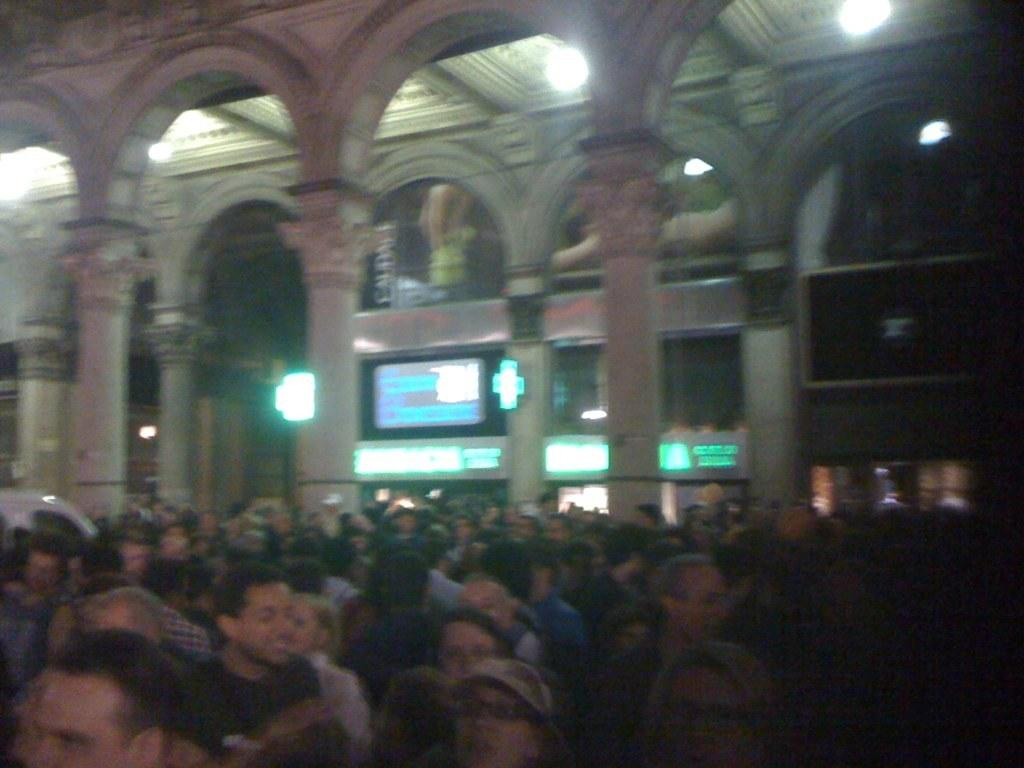Who or what can be seen in the image? There are people in the image. What can be seen in the background of the image? There are walls, lights, screens, and other objects in the background of the image. Can you describe the walls in the background? The walls in the background are visible but no specific details about them can be determined from the image. What might the screens in the background be displaying? The screens in the background could be displaying various types of content, but it cannot be determined from the image. What type of lunch is being prepared in the image? There is no indication of any food or lunch preparation in the image. 